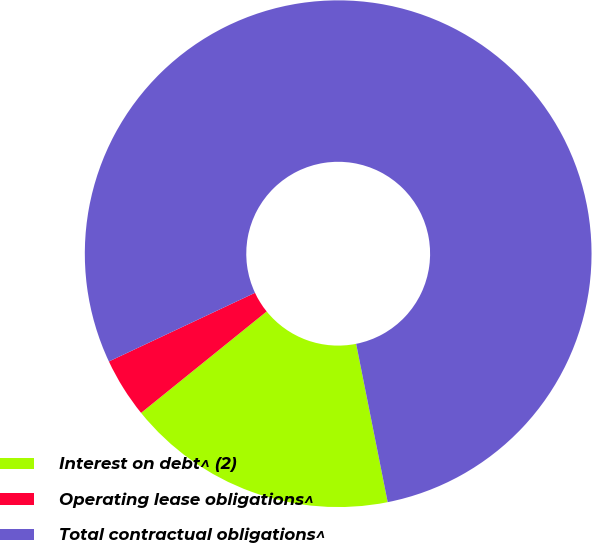Convert chart to OTSL. <chart><loc_0><loc_0><loc_500><loc_500><pie_chart><fcel>Interest on debt^ (2)<fcel>Operating lease obligations^<fcel>Total contractual obligations^<nl><fcel>17.32%<fcel>3.82%<fcel>78.87%<nl></chart> 